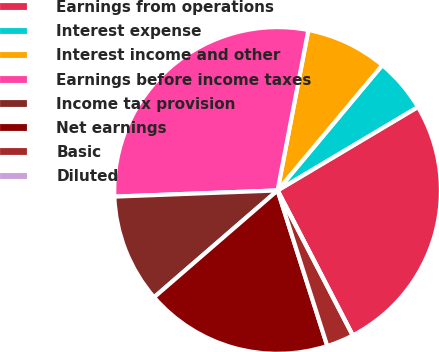Convert chart. <chart><loc_0><loc_0><loc_500><loc_500><pie_chart><fcel>Earnings from operations<fcel>Interest expense<fcel>Interest income and other<fcel>Earnings before income taxes<fcel>Income tax provision<fcel>Net earnings<fcel>Basic<fcel>Diluted<nl><fcel>25.93%<fcel>5.38%<fcel>8.06%<fcel>28.62%<fcel>10.75%<fcel>18.57%<fcel>2.69%<fcel>0.0%<nl></chart> 